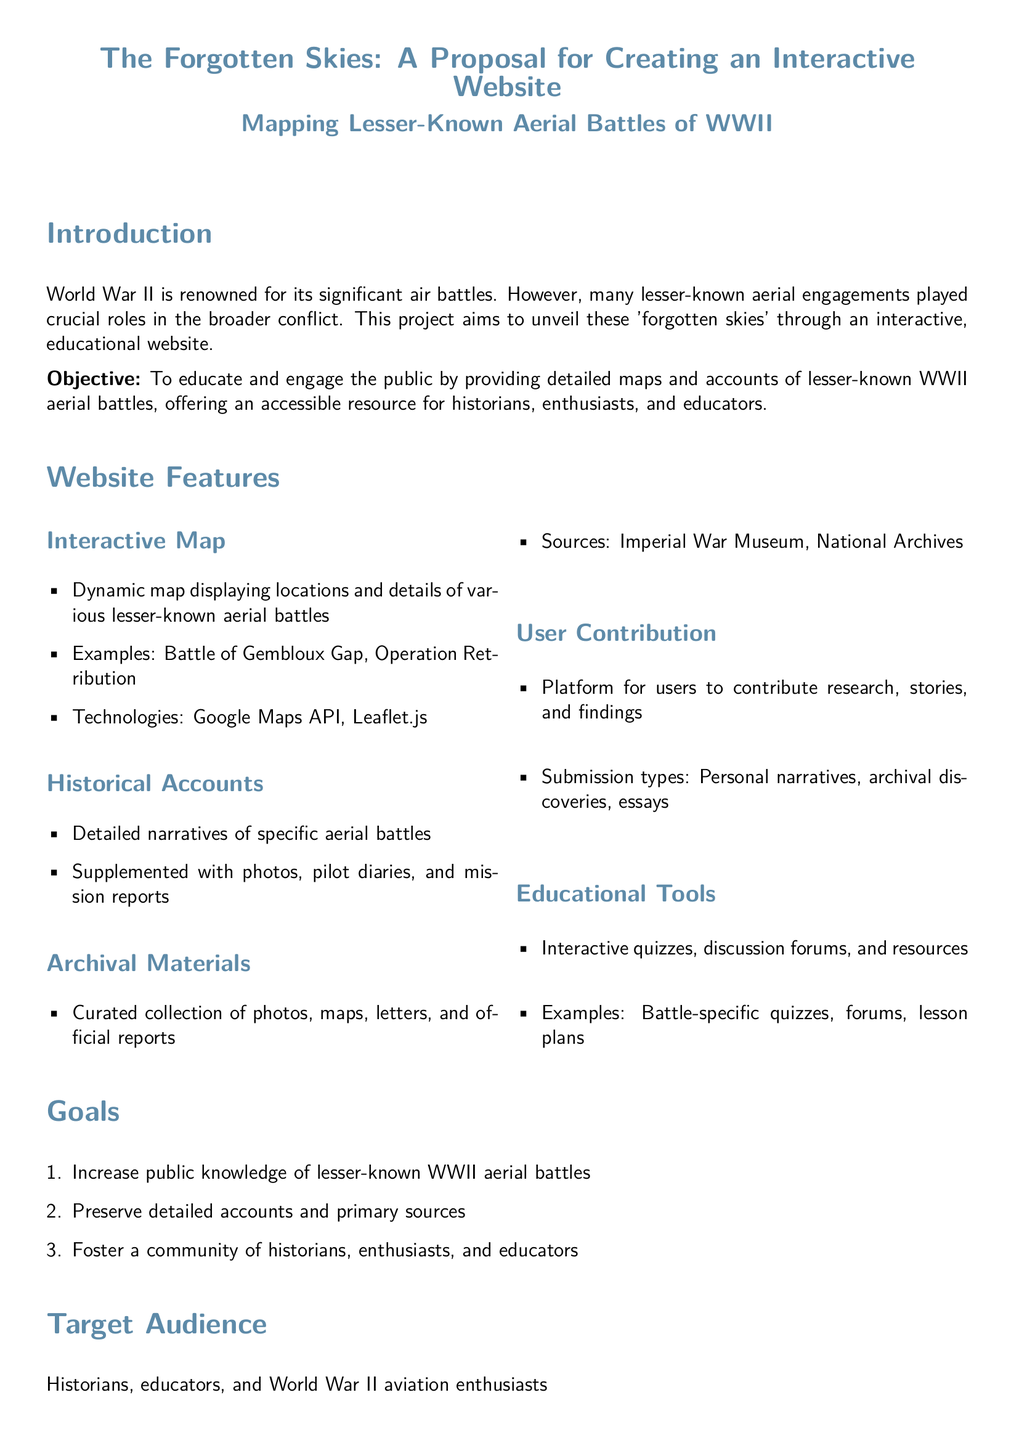what is the project title? The project title is stated in a prominent manner in the document.
Answer: The Forgotten Skies what is the main objective of the project? The objective is explicitly mentioned in the introduction section of the document.
Answer: To educate and engage the public how many phases are there in the timeline? The phases are outlined in the Timeline and Budget section of the document.
Answer: 3 what is the budget for the website development and testing phase? The budget for this specific phase is clearly listed in the table.
Answer: 20,000 USD which technologies will be used for the interactive map? The technologies are explicitly mentioned under the Website Features section of the document.
Answer: Google Maps API, Leaflet.js what type of materials will be included in the Archival Materials section? The types of materials are described in the corresponding subsection of the document.
Answer: Photos, maps, letters, and official reports who is the target audience for the website? The target audience is specified in a dedicated section of the document.
Answer: Historians, educators, and World War II aviation enthusiasts what is the total duration of the project? The total duration is calculated based on the phases outlined in the timeline of the document.
Answer: 9 months which battle is mentioned as an example in the interactive map? An example is provided in the Website Features section.
Answer: Battle of Gembloux Gap 